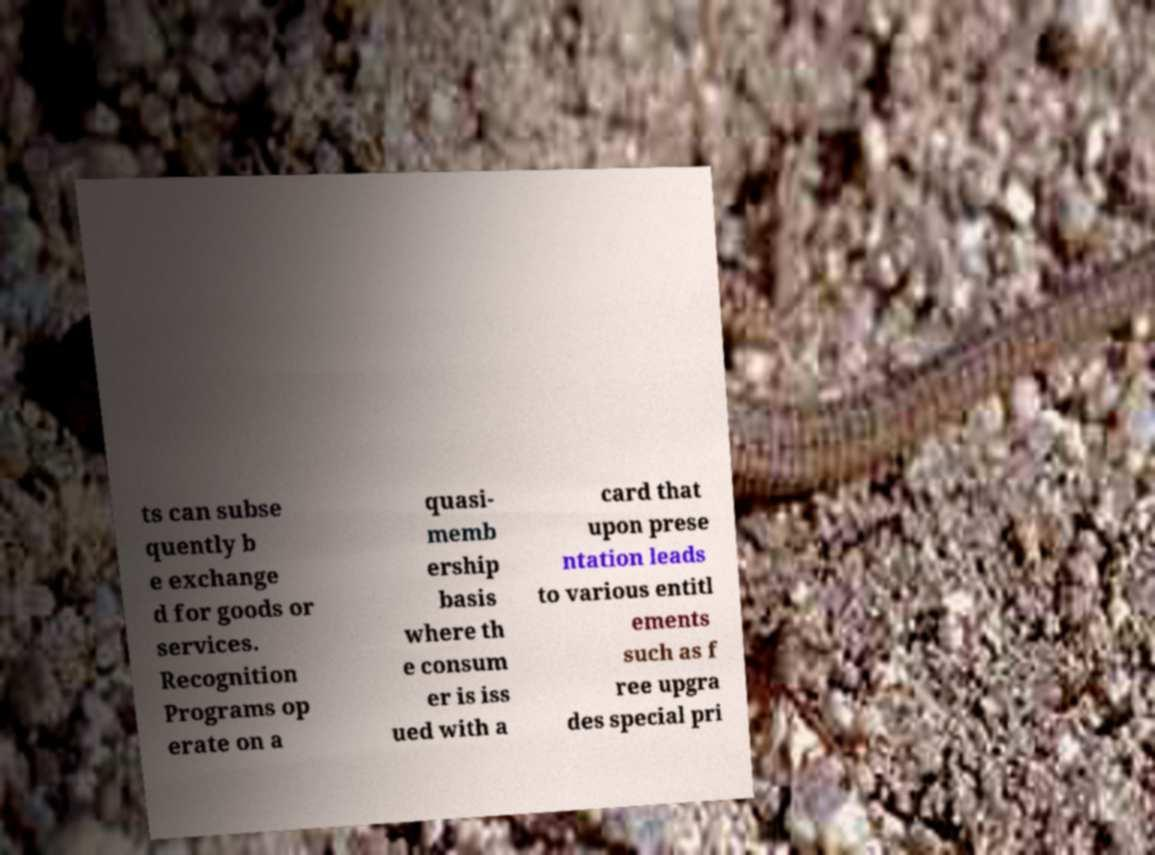Please identify and transcribe the text found in this image. ts can subse quently b e exchange d for goods or services. Recognition Programs op erate on a quasi- memb ership basis where th e consum er is iss ued with a card that upon prese ntation leads to various entitl ements such as f ree upgra des special pri 